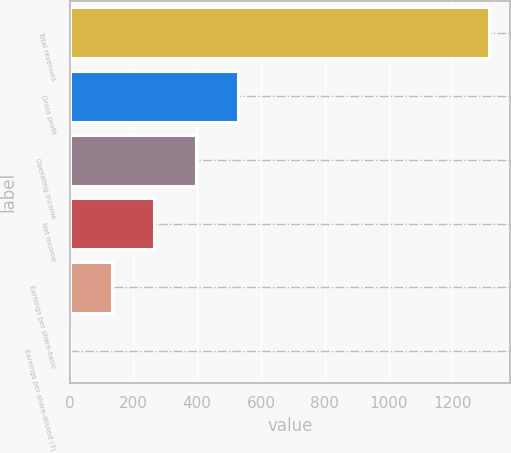<chart> <loc_0><loc_0><loc_500><loc_500><bar_chart><fcel>Total revenues<fcel>Gross profit<fcel>Operating income<fcel>Net income<fcel>Earnings per share-basic<fcel>Earnings per share-diluted (3)<nl><fcel>1315<fcel>526.68<fcel>395.3<fcel>263.92<fcel>132.54<fcel>1.16<nl></chart> 